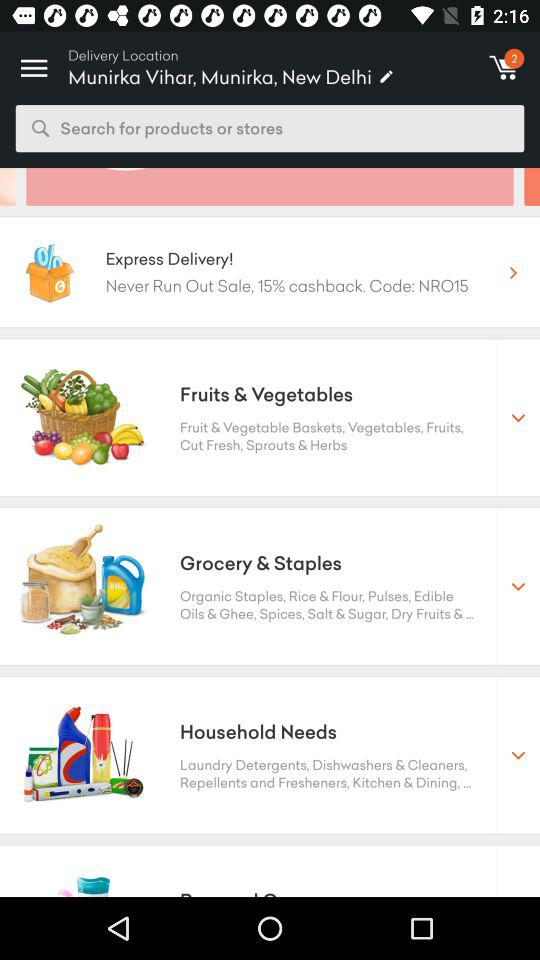How many items are there in the cart? There are 2 items in the cart. 